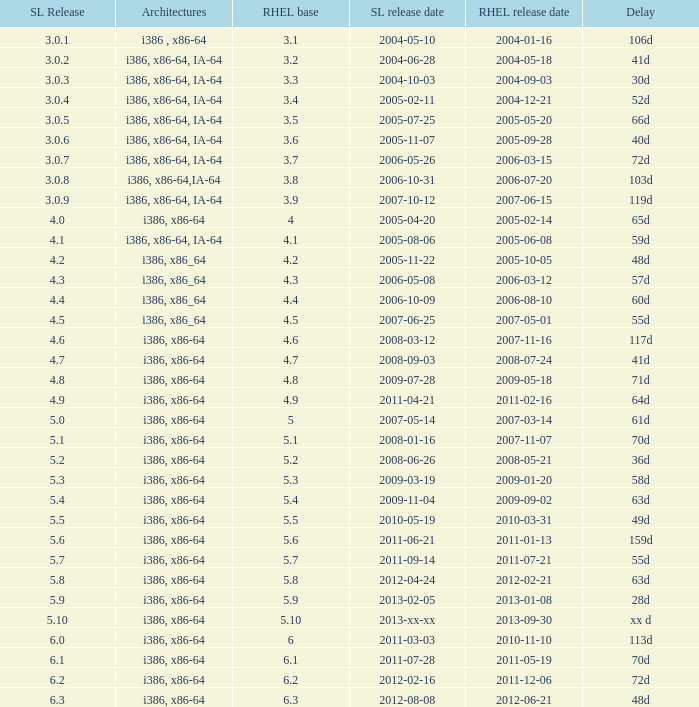When is the rhel release date when scientific linux release is 3.0.4 2004-12-21. 